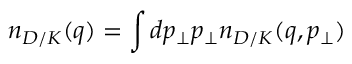Convert formula to latex. <formula><loc_0><loc_0><loc_500><loc_500>n _ { D / K } ( q ) = \int d p _ { \bot } p _ { \bot } n _ { D / K } ( q , p _ { \bot } )</formula> 